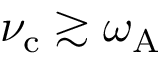<formula> <loc_0><loc_0><loc_500><loc_500>\nu _ { c } \gtrsim \omega _ { A }</formula> 